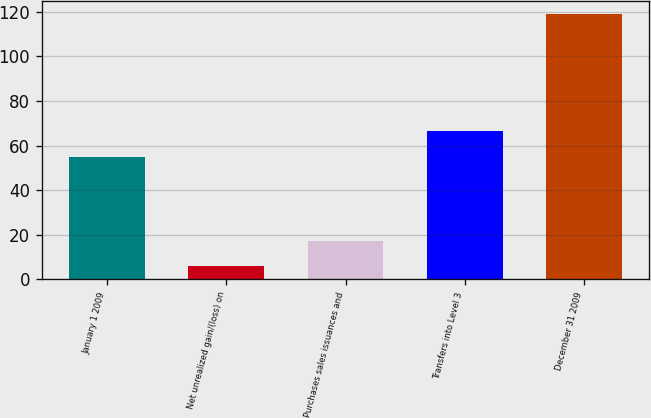Convert chart. <chart><loc_0><loc_0><loc_500><loc_500><bar_chart><fcel>January 1 2009<fcel>Net unrealized gain/(loss) on<fcel>Purchases sales issuances and<fcel>Transfers into Level 3<fcel>December 31 2009<nl><fcel>55<fcel>6<fcel>17.3<fcel>66.3<fcel>119<nl></chart> 